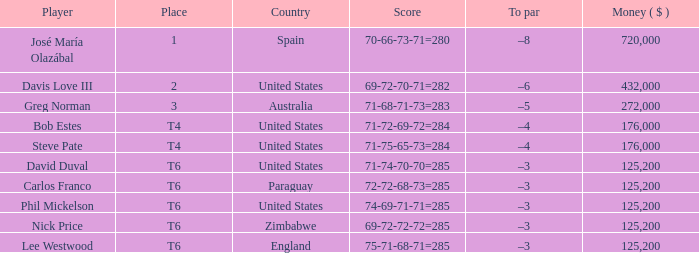Which Place has a To par of –8? 1.0. 